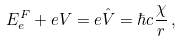<formula> <loc_0><loc_0><loc_500><loc_500>E ^ { F } _ { e } + e V = e \hat { V } = \hbar { c } \frac { \chi } { r } \, ,</formula> 